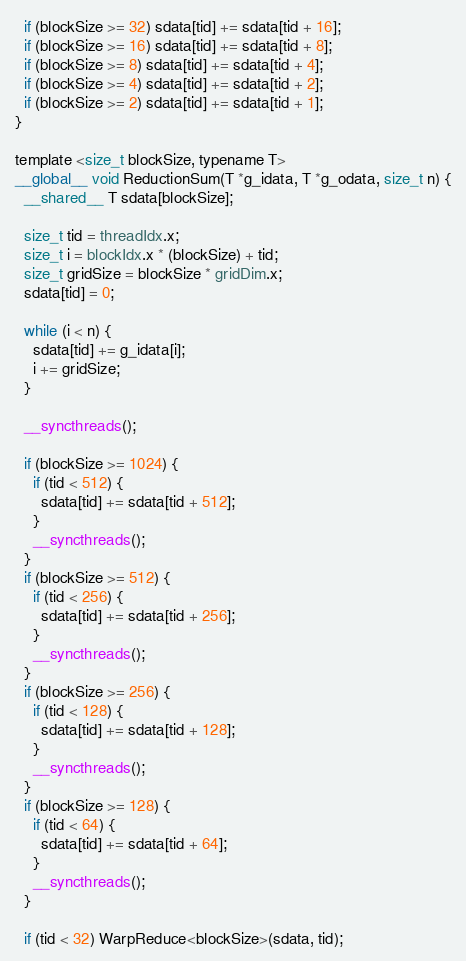Convert code to text. <code><loc_0><loc_0><loc_500><loc_500><_Cuda_>  if (blockSize >= 32) sdata[tid] += sdata[tid + 16];
  if (blockSize >= 16) sdata[tid] += sdata[tid + 8];
  if (blockSize >= 8) sdata[tid] += sdata[tid + 4];
  if (blockSize >= 4) sdata[tid] += sdata[tid + 2];
  if (blockSize >= 2) sdata[tid] += sdata[tid + 1];
}

template <size_t blockSize, typename T>
__global__ void ReductionSum(T *g_idata, T *g_odata, size_t n) {
  __shared__ T sdata[blockSize];

  size_t tid = threadIdx.x;
  size_t i = blockIdx.x * (blockSize) + tid;
  size_t gridSize = blockSize * gridDim.x;
  sdata[tid] = 0;

  while (i < n) {
    sdata[tid] += g_idata[i];
    i += gridSize;
  }

  __syncthreads();

  if (blockSize >= 1024) {
    if (tid < 512) {
      sdata[tid] += sdata[tid + 512];
    }
    __syncthreads();
  }
  if (blockSize >= 512) {
    if (tid < 256) {
      sdata[tid] += sdata[tid + 256];
    }
    __syncthreads();
  }
  if (blockSize >= 256) {
    if (tid < 128) {
      sdata[tid] += sdata[tid + 128];
    }
    __syncthreads();
  }
  if (blockSize >= 128) {
    if (tid < 64) {
      sdata[tid] += sdata[tid + 64];
    }
    __syncthreads();
  }

  if (tid < 32) WarpReduce<blockSize>(sdata, tid);</code> 